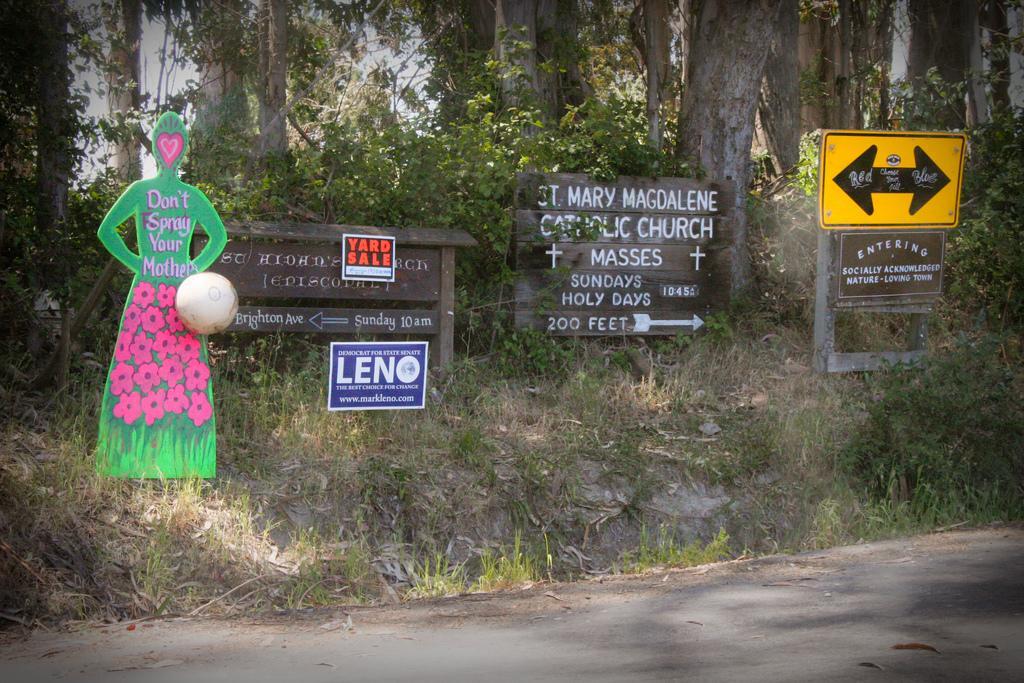Can you describe this image briefly? This image is taken outdoors. At the bottom of the image there is a road. In the background there is a ground with grass on it. There are many trees and plants. In the middle of the image there are many boards with text on them. 